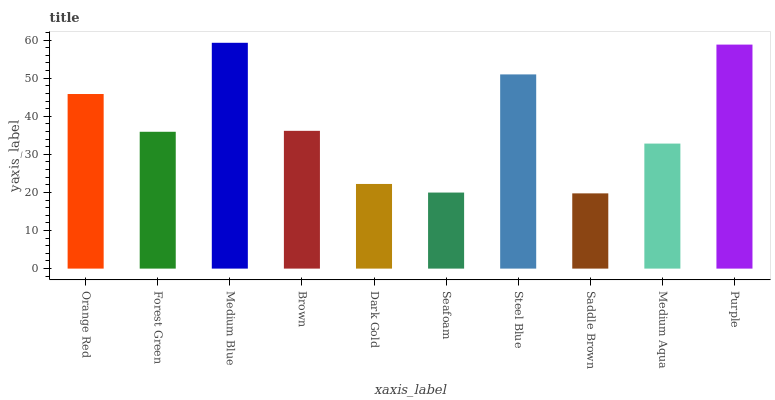Is Saddle Brown the minimum?
Answer yes or no. Yes. Is Medium Blue the maximum?
Answer yes or no. Yes. Is Forest Green the minimum?
Answer yes or no. No. Is Forest Green the maximum?
Answer yes or no. No. Is Orange Red greater than Forest Green?
Answer yes or no. Yes. Is Forest Green less than Orange Red?
Answer yes or no. Yes. Is Forest Green greater than Orange Red?
Answer yes or no. No. Is Orange Red less than Forest Green?
Answer yes or no. No. Is Brown the high median?
Answer yes or no. Yes. Is Forest Green the low median?
Answer yes or no. Yes. Is Seafoam the high median?
Answer yes or no. No. Is Seafoam the low median?
Answer yes or no. No. 